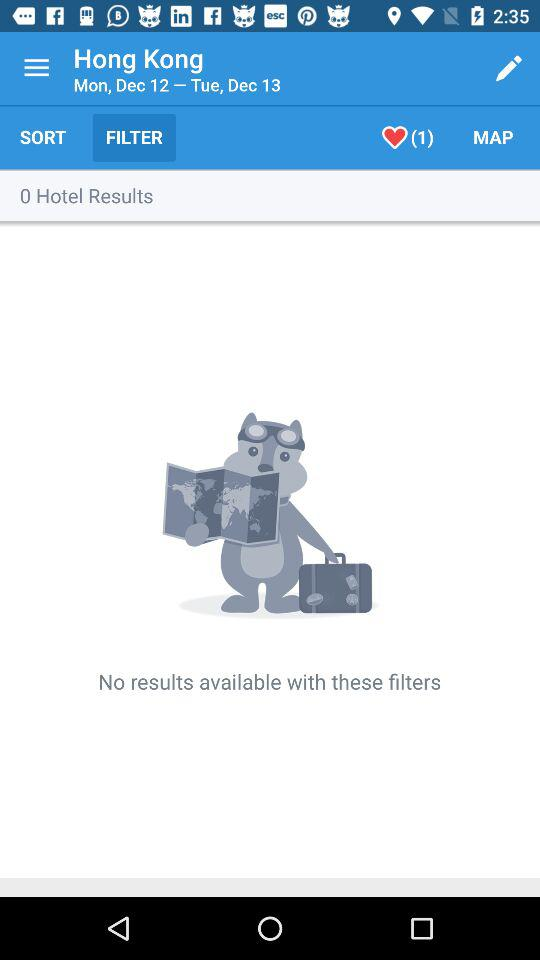How many likes are there? There is only 1 like. 